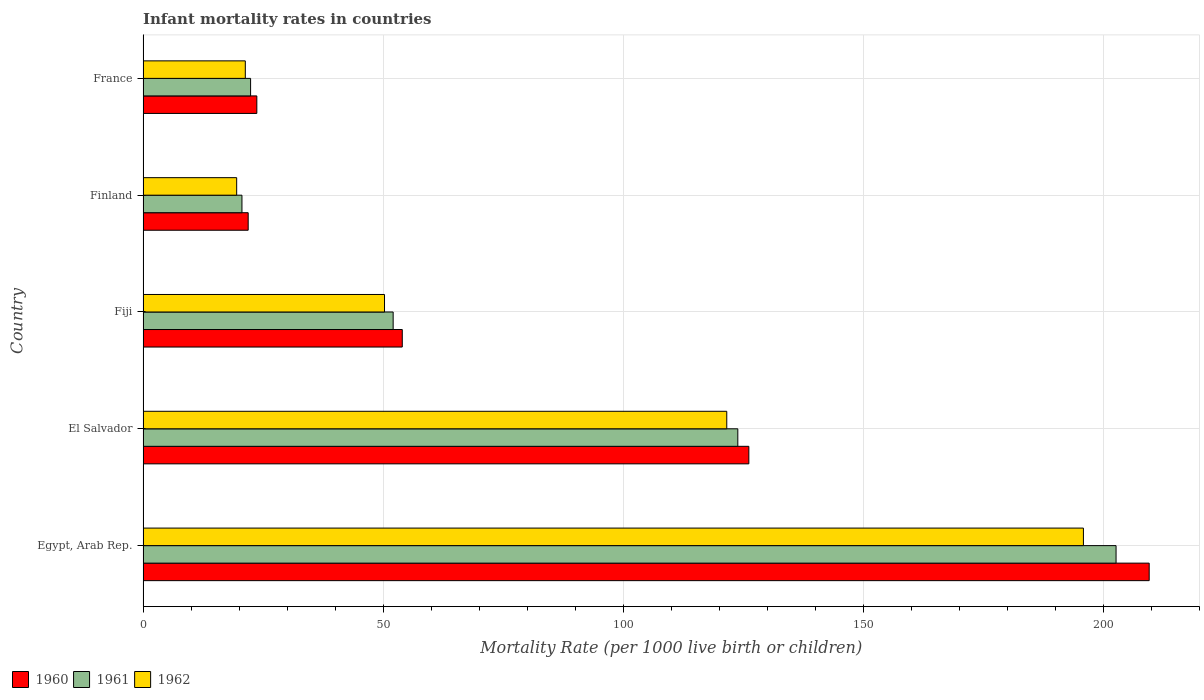How many groups of bars are there?
Your response must be concise. 5. How many bars are there on the 1st tick from the bottom?
Keep it short and to the point. 3. What is the label of the 4th group of bars from the top?
Provide a short and direct response. El Salvador. In how many cases, is the number of bars for a given country not equal to the number of legend labels?
Your response must be concise. 0. What is the infant mortality rate in 1960 in El Salvador?
Offer a terse response. 126.2. Across all countries, what is the maximum infant mortality rate in 1961?
Keep it short and to the point. 202.7. Across all countries, what is the minimum infant mortality rate in 1960?
Keep it short and to the point. 21.9. In which country was the infant mortality rate in 1962 maximum?
Your response must be concise. Egypt, Arab Rep. In which country was the infant mortality rate in 1962 minimum?
Make the answer very short. Finland. What is the total infant mortality rate in 1961 in the graph?
Offer a terse response. 421.7. What is the difference between the infant mortality rate in 1960 in El Salvador and that in France?
Offer a very short reply. 102.5. What is the difference between the infant mortality rate in 1961 in El Salvador and the infant mortality rate in 1962 in Fiji?
Offer a very short reply. 73.6. What is the average infant mortality rate in 1962 per country?
Your response must be concise. 81.72. What is the difference between the infant mortality rate in 1962 and infant mortality rate in 1960 in El Salvador?
Offer a terse response. -4.6. What is the ratio of the infant mortality rate in 1962 in El Salvador to that in France?
Give a very brief answer. 5.71. Is the difference between the infant mortality rate in 1962 in Egypt, Arab Rep. and Fiji greater than the difference between the infant mortality rate in 1960 in Egypt, Arab Rep. and Fiji?
Give a very brief answer. No. What is the difference between the highest and the second highest infant mortality rate in 1962?
Ensure brevity in your answer.  74.3. What is the difference between the highest and the lowest infant mortality rate in 1961?
Keep it short and to the point. 182.1. Is the sum of the infant mortality rate in 1960 in Egypt, Arab Rep. and Fiji greater than the maximum infant mortality rate in 1962 across all countries?
Make the answer very short. Yes. What does the 3rd bar from the top in Egypt, Arab Rep. represents?
Keep it short and to the point. 1960. How many bars are there?
Provide a succinct answer. 15. Are all the bars in the graph horizontal?
Your response must be concise. Yes. Are the values on the major ticks of X-axis written in scientific E-notation?
Give a very brief answer. No. How many legend labels are there?
Your answer should be compact. 3. What is the title of the graph?
Give a very brief answer. Infant mortality rates in countries. What is the label or title of the X-axis?
Give a very brief answer. Mortality Rate (per 1000 live birth or children). What is the label or title of the Y-axis?
Provide a short and direct response. Country. What is the Mortality Rate (per 1000 live birth or children) in 1960 in Egypt, Arab Rep.?
Provide a succinct answer. 209.6. What is the Mortality Rate (per 1000 live birth or children) of 1961 in Egypt, Arab Rep.?
Keep it short and to the point. 202.7. What is the Mortality Rate (per 1000 live birth or children) in 1962 in Egypt, Arab Rep.?
Your answer should be compact. 195.9. What is the Mortality Rate (per 1000 live birth or children) of 1960 in El Salvador?
Your answer should be compact. 126.2. What is the Mortality Rate (per 1000 live birth or children) in 1961 in El Salvador?
Make the answer very short. 123.9. What is the Mortality Rate (per 1000 live birth or children) of 1962 in El Salvador?
Provide a succinct answer. 121.6. What is the Mortality Rate (per 1000 live birth or children) of 1961 in Fiji?
Provide a succinct answer. 52.1. What is the Mortality Rate (per 1000 live birth or children) of 1962 in Fiji?
Give a very brief answer. 50.3. What is the Mortality Rate (per 1000 live birth or children) in 1960 in Finland?
Provide a short and direct response. 21.9. What is the Mortality Rate (per 1000 live birth or children) in 1961 in Finland?
Offer a terse response. 20.6. What is the Mortality Rate (per 1000 live birth or children) of 1960 in France?
Give a very brief answer. 23.7. What is the Mortality Rate (per 1000 live birth or children) of 1961 in France?
Your answer should be very brief. 22.4. What is the Mortality Rate (per 1000 live birth or children) of 1962 in France?
Ensure brevity in your answer.  21.3. Across all countries, what is the maximum Mortality Rate (per 1000 live birth or children) of 1960?
Offer a terse response. 209.6. Across all countries, what is the maximum Mortality Rate (per 1000 live birth or children) of 1961?
Offer a terse response. 202.7. Across all countries, what is the maximum Mortality Rate (per 1000 live birth or children) of 1962?
Give a very brief answer. 195.9. Across all countries, what is the minimum Mortality Rate (per 1000 live birth or children) in 1960?
Offer a terse response. 21.9. Across all countries, what is the minimum Mortality Rate (per 1000 live birth or children) in 1961?
Provide a short and direct response. 20.6. Across all countries, what is the minimum Mortality Rate (per 1000 live birth or children) in 1962?
Ensure brevity in your answer.  19.5. What is the total Mortality Rate (per 1000 live birth or children) of 1960 in the graph?
Offer a terse response. 435.4. What is the total Mortality Rate (per 1000 live birth or children) in 1961 in the graph?
Keep it short and to the point. 421.7. What is the total Mortality Rate (per 1000 live birth or children) in 1962 in the graph?
Offer a terse response. 408.6. What is the difference between the Mortality Rate (per 1000 live birth or children) of 1960 in Egypt, Arab Rep. and that in El Salvador?
Your answer should be compact. 83.4. What is the difference between the Mortality Rate (per 1000 live birth or children) of 1961 in Egypt, Arab Rep. and that in El Salvador?
Your answer should be very brief. 78.8. What is the difference between the Mortality Rate (per 1000 live birth or children) of 1962 in Egypt, Arab Rep. and that in El Salvador?
Provide a succinct answer. 74.3. What is the difference between the Mortality Rate (per 1000 live birth or children) in 1960 in Egypt, Arab Rep. and that in Fiji?
Give a very brief answer. 155.6. What is the difference between the Mortality Rate (per 1000 live birth or children) of 1961 in Egypt, Arab Rep. and that in Fiji?
Make the answer very short. 150.6. What is the difference between the Mortality Rate (per 1000 live birth or children) in 1962 in Egypt, Arab Rep. and that in Fiji?
Your answer should be very brief. 145.6. What is the difference between the Mortality Rate (per 1000 live birth or children) of 1960 in Egypt, Arab Rep. and that in Finland?
Keep it short and to the point. 187.7. What is the difference between the Mortality Rate (per 1000 live birth or children) of 1961 in Egypt, Arab Rep. and that in Finland?
Offer a very short reply. 182.1. What is the difference between the Mortality Rate (per 1000 live birth or children) in 1962 in Egypt, Arab Rep. and that in Finland?
Offer a terse response. 176.4. What is the difference between the Mortality Rate (per 1000 live birth or children) in 1960 in Egypt, Arab Rep. and that in France?
Keep it short and to the point. 185.9. What is the difference between the Mortality Rate (per 1000 live birth or children) in 1961 in Egypt, Arab Rep. and that in France?
Offer a very short reply. 180.3. What is the difference between the Mortality Rate (per 1000 live birth or children) in 1962 in Egypt, Arab Rep. and that in France?
Make the answer very short. 174.6. What is the difference between the Mortality Rate (per 1000 live birth or children) of 1960 in El Salvador and that in Fiji?
Provide a succinct answer. 72.2. What is the difference between the Mortality Rate (per 1000 live birth or children) of 1961 in El Salvador and that in Fiji?
Your response must be concise. 71.8. What is the difference between the Mortality Rate (per 1000 live birth or children) of 1962 in El Salvador and that in Fiji?
Your answer should be very brief. 71.3. What is the difference between the Mortality Rate (per 1000 live birth or children) of 1960 in El Salvador and that in Finland?
Offer a very short reply. 104.3. What is the difference between the Mortality Rate (per 1000 live birth or children) of 1961 in El Salvador and that in Finland?
Keep it short and to the point. 103.3. What is the difference between the Mortality Rate (per 1000 live birth or children) in 1962 in El Salvador and that in Finland?
Offer a very short reply. 102.1. What is the difference between the Mortality Rate (per 1000 live birth or children) of 1960 in El Salvador and that in France?
Provide a succinct answer. 102.5. What is the difference between the Mortality Rate (per 1000 live birth or children) of 1961 in El Salvador and that in France?
Your response must be concise. 101.5. What is the difference between the Mortality Rate (per 1000 live birth or children) in 1962 in El Salvador and that in France?
Ensure brevity in your answer.  100.3. What is the difference between the Mortality Rate (per 1000 live birth or children) of 1960 in Fiji and that in Finland?
Your response must be concise. 32.1. What is the difference between the Mortality Rate (per 1000 live birth or children) of 1961 in Fiji and that in Finland?
Offer a terse response. 31.5. What is the difference between the Mortality Rate (per 1000 live birth or children) of 1962 in Fiji and that in Finland?
Ensure brevity in your answer.  30.8. What is the difference between the Mortality Rate (per 1000 live birth or children) in 1960 in Fiji and that in France?
Make the answer very short. 30.3. What is the difference between the Mortality Rate (per 1000 live birth or children) of 1961 in Fiji and that in France?
Provide a succinct answer. 29.7. What is the difference between the Mortality Rate (per 1000 live birth or children) in 1962 in Fiji and that in France?
Offer a very short reply. 29. What is the difference between the Mortality Rate (per 1000 live birth or children) in 1962 in Finland and that in France?
Make the answer very short. -1.8. What is the difference between the Mortality Rate (per 1000 live birth or children) in 1960 in Egypt, Arab Rep. and the Mortality Rate (per 1000 live birth or children) in 1961 in El Salvador?
Your answer should be compact. 85.7. What is the difference between the Mortality Rate (per 1000 live birth or children) of 1960 in Egypt, Arab Rep. and the Mortality Rate (per 1000 live birth or children) of 1962 in El Salvador?
Give a very brief answer. 88. What is the difference between the Mortality Rate (per 1000 live birth or children) of 1961 in Egypt, Arab Rep. and the Mortality Rate (per 1000 live birth or children) of 1962 in El Salvador?
Provide a succinct answer. 81.1. What is the difference between the Mortality Rate (per 1000 live birth or children) of 1960 in Egypt, Arab Rep. and the Mortality Rate (per 1000 live birth or children) of 1961 in Fiji?
Keep it short and to the point. 157.5. What is the difference between the Mortality Rate (per 1000 live birth or children) of 1960 in Egypt, Arab Rep. and the Mortality Rate (per 1000 live birth or children) of 1962 in Fiji?
Offer a very short reply. 159.3. What is the difference between the Mortality Rate (per 1000 live birth or children) of 1961 in Egypt, Arab Rep. and the Mortality Rate (per 1000 live birth or children) of 1962 in Fiji?
Provide a succinct answer. 152.4. What is the difference between the Mortality Rate (per 1000 live birth or children) of 1960 in Egypt, Arab Rep. and the Mortality Rate (per 1000 live birth or children) of 1961 in Finland?
Your answer should be compact. 189. What is the difference between the Mortality Rate (per 1000 live birth or children) of 1960 in Egypt, Arab Rep. and the Mortality Rate (per 1000 live birth or children) of 1962 in Finland?
Ensure brevity in your answer.  190.1. What is the difference between the Mortality Rate (per 1000 live birth or children) of 1961 in Egypt, Arab Rep. and the Mortality Rate (per 1000 live birth or children) of 1962 in Finland?
Offer a very short reply. 183.2. What is the difference between the Mortality Rate (per 1000 live birth or children) of 1960 in Egypt, Arab Rep. and the Mortality Rate (per 1000 live birth or children) of 1961 in France?
Your response must be concise. 187.2. What is the difference between the Mortality Rate (per 1000 live birth or children) in 1960 in Egypt, Arab Rep. and the Mortality Rate (per 1000 live birth or children) in 1962 in France?
Provide a succinct answer. 188.3. What is the difference between the Mortality Rate (per 1000 live birth or children) in 1961 in Egypt, Arab Rep. and the Mortality Rate (per 1000 live birth or children) in 1962 in France?
Provide a short and direct response. 181.4. What is the difference between the Mortality Rate (per 1000 live birth or children) of 1960 in El Salvador and the Mortality Rate (per 1000 live birth or children) of 1961 in Fiji?
Your response must be concise. 74.1. What is the difference between the Mortality Rate (per 1000 live birth or children) in 1960 in El Salvador and the Mortality Rate (per 1000 live birth or children) in 1962 in Fiji?
Provide a succinct answer. 75.9. What is the difference between the Mortality Rate (per 1000 live birth or children) of 1961 in El Salvador and the Mortality Rate (per 1000 live birth or children) of 1962 in Fiji?
Make the answer very short. 73.6. What is the difference between the Mortality Rate (per 1000 live birth or children) of 1960 in El Salvador and the Mortality Rate (per 1000 live birth or children) of 1961 in Finland?
Offer a very short reply. 105.6. What is the difference between the Mortality Rate (per 1000 live birth or children) of 1960 in El Salvador and the Mortality Rate (per 1000 live birth or children) of 1962 in Finland?
Provide a succinct answer. 106.7. What is the difference between the Mortality Rate (per 1000 live birth or children) of 1961 in El Salvador and the Mortality Rate (per 1000 live birth or children) of 1962 in Finland?
Your response must be concise. 104.4. What is the difference between the Mortality Rate (per 1000 live birth or children) of 1960 in El Salvador and the Mortality Rate (per 1000 live birth or children) of 1961 in France?
Ensure brevity in your answer.  103.8. What is the difference between the Mortality Rate (per 1000 live birth or children) in 1960 in El Salvador and the Mortality Rate (per 1000 live birth or children) in 1962 in France?
Your answer should be compact. 104.9. What is the difference between the Mortality Rate (per 1000 live birth or children) in 1961 in El Salvador and the Mortality Rate (per 1000 live birth or children) in 1962 in France?
Ensure brevity in your answer.  102.6. What is the difference between the Mortality Rate (per 1000 live birth or children) in 1960 in Fiji and the Mortality Rate (per 1000 live birth or children) in 1961 in Finland?
Provide a short and direct response. 33.4. What is the difference between the Mortality Rate (per 1000 live birth or children) of 1960 in Fiji and the Mortality Rate (per 1000 live birth or children) of 1962 in Finland?
Your response must be concise. 34.5. What is the difference between the Mortality Rate (per 1000 live birth or children) of 1961 in Fiji and the Mortality Rate (per 1000 live birth or children) of 1962 in Finland?
Your answer should be very brief. 32.6. What is the difference between the Mortality Rate (per 1000 live birth or children) in 1960 in Fiji and the Mortality Rate (per 1000 live birth or children) in 1961 in France?
Provide a succinct answer. 31.6. What is the difference between the Mortality Rate (per 1000 live birth or children) in 1960 in Fiji and the Mortality Rate (per 1000 live birth or children) in 1962 in France?
Provide a short and direct response. 32.7. What is the difference between the Mortality Rate (per 1000 live birth or children) in 1961 in Fiji and the Mortality Rate (per 1000 live birth or children) in 1962 in France?
Offer a very short reply. 30.8. What is the difference between the Mortality Rate (per 1000 live birth or children) of 1960 in Finland and the Mortality Rate (per 1000 live birth or children) of 1961 in France?
Give a very brief answer. -0.5. What is the difference between the Mortality Rate (per 1000 live birth or children) in 1961 in Finland and the Mortality Rate (per 1000 live birth or children) in 1962 in France?
Offer a terse response. -0.7. What is the average Mortality Rate (per 1000 live birth or children) of 1960 per country?
Offer a very short reply. 87.08. What is the average Mortality Rate (per 1000 live birth or children) in 1961 per country?
Provide a succinct answer. 84.34. What is the average Mortality Rate (per 1000 live birth or children) of 1962 per country?
Your answer should be very brief. 81.72. What is the difference between the Mortality Rate (per 1000 live birth or children) in 1961 and Mortality Rate (per 1000 live birth or children) in 1962 in Egypt, Arab Rep.?
Offer a very short reply. 6.8. What is the difference between the Mortality Rate (per 1000 live birth or children) in 1961 and Mortality Rate (per 1000 live birth or children) in 1962 in El Salvador?
Provide a short and direct response. 2.3. What is the difference between the Mortality Rate (per 1000 live birth or children) of 1960 and Mortality Rate (per 1000 live birth or children) of 1961 in Fiji?
Keep it short and to the point. 1.9. What is the difference between the Mortality Rate (per 1000 live birth or children) in 1960 and Mortality Rate (per 1000 live birth or children) in 1961 in Finland?
Provide a short and direct response. 1.3. What is the difference between the Mortality Rate (per 1000 live birth or children) of 1960 and Mortality Rate (per 1000 live birth or children) of 1961 in France?
Make the answer very short. 1.3. What is the difference between the Mortality Rate (per 1000 live birth or children) in 1960 and Mortality Rate (per 1000 live birth or children) in 1962 in France?
Offer a very short reply. 2.4. What is the ratio of the Mortality Rate (per 1000 live birth or children) of 1960 in Egypt, Arab Rep. to that in El Salvador?
Your answer should be compact. 1.66. What is the ratio of the Mortality Rate (per 1000 live birth or children) of 1961 in Egypt, Arab Rep. to that in El Salvador?
Provide a succinct answer. 1.64. What is the ratio of the Mortality Rate (per 1000 live birth or children) in 1962 in Egypt, Arab Rep. to that in El Salvador?
Your answer should be very brief. 1.61. What is the ratio of the Mortality Rate (per 1000 live birth or children) in 1960 in Egypt, Arab Rep. to that in Fiji?
Keep it short and to the point. 3.88. What is the ratio of the Mortality Rate (per 1000 live birth or children) of 1961 in Egypt, Arab Rep. to that in Fiji?
Keep it short and to the point. 3.89. What is the ratio of the Mortality Rate (per 1000 live birth or children) in 1962 in Egypt, Arab Rep. to that in Fiji?
Provide a succinct answer. 3.89. What is the ratio of the Mortality Rate (per 1000 live birth or children) of 1960 in Egypt, Arab Rep. to that in Finland?
Provide a short and direct response. 9.57. What is the ratio of the Mortality Rate (per 1000 live birth or children) of 1961 in Egypt, Arab Rep. to that in Finland?
Provide a short and direct response. 9.84. What is the ratio of the Mortality Rate (per 1000 live birth or children) of 1962 in Egypt, Arab Rep. to that in Finland?
Make the answer very short. 10.05. What is the ratio of the Mortality Rate (per 1000 live birth or children) in 1960 in Egypt, Arab Rep. to that in France?
Provide a succinct answer. 8.84. What is the ratio of the Mortality Rate (per 1000 live birth or children) of 1961 in Egypt, Arab Rep. to that in France?
Offer a terse response. 9.05. What is the ratio of the Mortality Rate (per 1000 live birth or children) in 1962 in Egypt, Arab Rep. to that in France?
Provide a succinct answer. 9.2. What is the ratio of the Mortality Rate (per 1000 live birth or children) of 1960 in El Salvador to that in Fiji?
Keep it short and to the point. 2.34. What is the ratio of the Mortality Rate (per 1000 live birth or children) of 1961 in El Salvador to that in Fiji?
Keep it short and to the point. 2.38. What is the ratio of the Mortality Rate (per 1000 live birth or children) of 1962 in El Salvador to that in Fiji?
Give a very brief answer. 2.42. What is the ratio of the Mortality Rate (per 1000 live birth or children) in 1960 in El Salvador to that in Finland?
Your answer should be compact. 5.76. What is the ratio of the Mortality Rate (per 1000 live birth or children) in 1961 in El Salvador to that in Finland?
Keep it short and to the point. 6.01. What is the ratio of the Mortality Rate (per 1000 live birth or children) of 1962 in El Salvador to that in Finland?
Offer a terse response. 6.24. What is the ratio of the Mortality Rate (per 1000 live birth or children) of 1960 in El Salvador to that in France?
Offer a terse response. 5.32. What is the ratio of the Mortality Rate (per 1000 live birth or children) of 1961 in El Salvador to that in France?
Keep it short and to the point. 5.53. What is the ratio of the Mortality Rate (per 1000 live birth or children) in 1962 in El Salvador to that in France?
Your response must be concise. 5.71. What is the ratio of the Mortality Rate (per 1000 live birth or children) of 1960 in Fiji to that in Finland?
Provide a short and direct response. 2.47. What is the ratio of the Mortality Rate (per 1000 live birth or children) in 1961 in Fiji to that in Finland?
Give a very brief answer. 2.53. What is the ratio of the Mortality Rate (per 1000 live birth or children) of 1962 in Fiji to that in Finland?
Keep it short and to the point. 2.58. What is the ratio of the Mortality Rate (per 1000 live birth or children) of 1960 in Fiji to that in France?
Provide a short and direct response. 2.28. What is the ratio of the Mortality Rate (per 1000 live birth or children) in 1961 in Fiji to that in France?
Your answer should be very brief. 2.33. What is the ratio of the Mortality Rate (per 1000 live birth or children) of 1962 in Fiji to that in France?
Your answer should be compact. 2.36. What is the ratio of the Mortality Rate (per 1000 live birth or children) in 1960 in Finland to that in France?
Provide a succinct answer. 0.92. What is the ratio of the Mortality Rate (per 1000 live birth or children) in 1961 in Finland to that in France?
Your response must be concise. 0.92. What is the ratio of the Mortality Rate (per 1000 live birth or children) of 1962 in Finland to that in France?
Your answer should be compact. 0.92. What is the difference between the highest and the second highest Mortality Rate (per 1000 live birth or children) in 1960?
Make the answer very short. 83.4. What is the difference between the highest and the second highest Mortality Rate (per 1000 live birth or children) of 1961?
Offer a terse response. 78.8. What is the difference between the highest and the second highest Mortality Rate (per 1000 live birth or children) in 1962?
Your response must be concise. 74.3. What is the difference between the highest and the lowest Mortality Rate (per 1000 live birth or children) of 1960?
Provide a short and direct response. 187.7. What is the difference between the highest and the lowest Mortality Rate (per 1000 live birth or children) of 1961?
Offer a terse response. 182.1. What is the difference between the highest and the lowest Mortality Rate (per 1000 live birth or children) in 1962?
Your answer should be very brief. 176.4. 